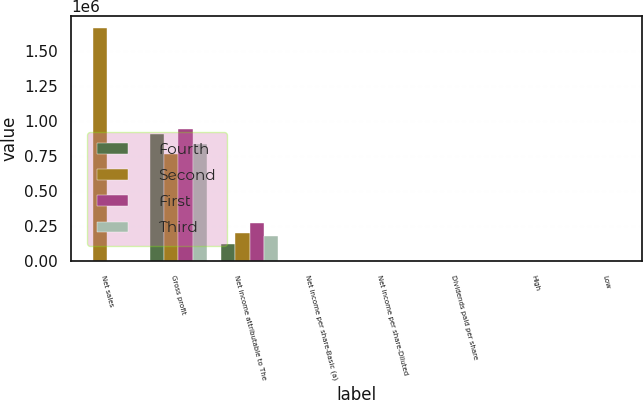Convert chart. <chart><loc_0><loc_0><loc_500><loc_500><stacked_bar_chart><ecel><fcel>Net sales<fcel>Gross profit<fcel>Net income attributable to The<fcel>Net income per share-Basic (a)<fcel>Net income per share-Diluted<fcel>Dividends paid per share<fcel>High<fcel>Low<nl><fcel>Fourth<fcel>104.06<fcel>909352<fcel>125044<fcel>0.6<fcel>0.58<fcel>0.62<fcel>109.61<fcel>103.45<nl><fcel>Second<fcel>1.66299e+06<fcel>765847<fcel>203501<fcel>0.98<fcel>0.95<fcel>0.62<fcel>115.96<fcel>106.41<nl><fcel>First<fcel>104.06<fcel>942936<fcel>273303<fcel>1.32<fcel>1.28<fcel>0.66<fcel>110.5<fcel>104.06<nl><fcel>Third<fcel>104.06<fcel>837241<fcel>181133<fcel>0.88<fcel>0.85<fcel>0.66<fcel>115.45<fcel>102.87<nl></chart> 